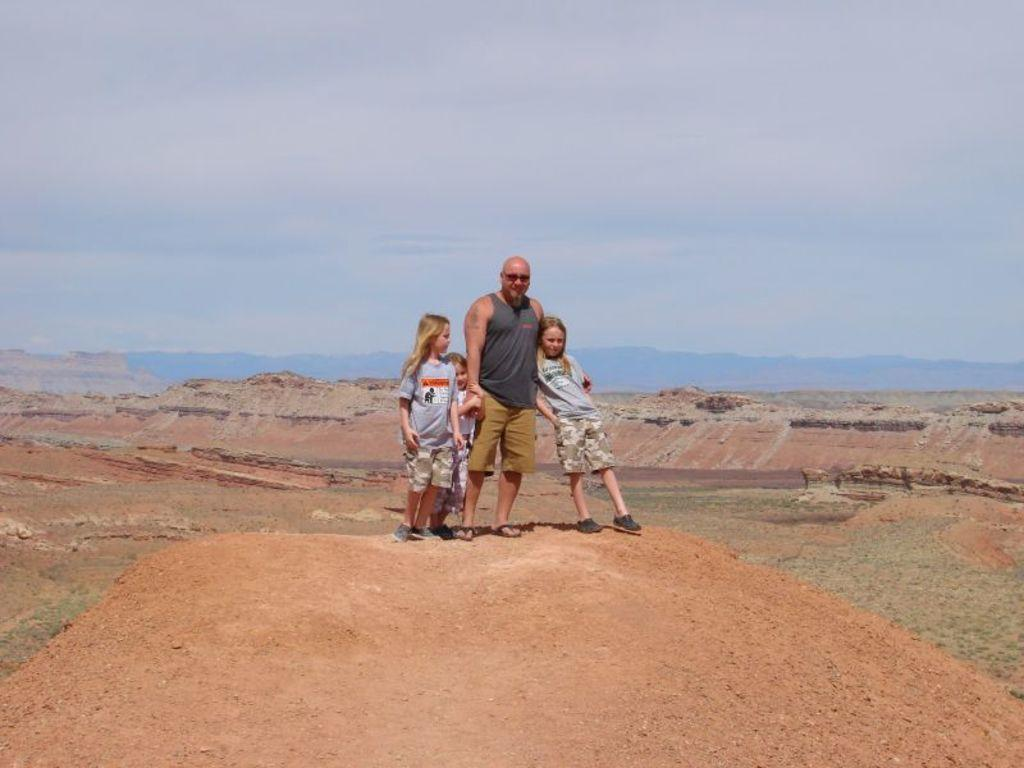How many people are in the image? There are four people standing in the front of the image. What can be seen in the background of the image? There are trees in the background of the image. What is visible at the top of the image? The sky is visible at the top of the image. What type of pets can be seen playing with balls in the image? There are no pets visible in the image. 